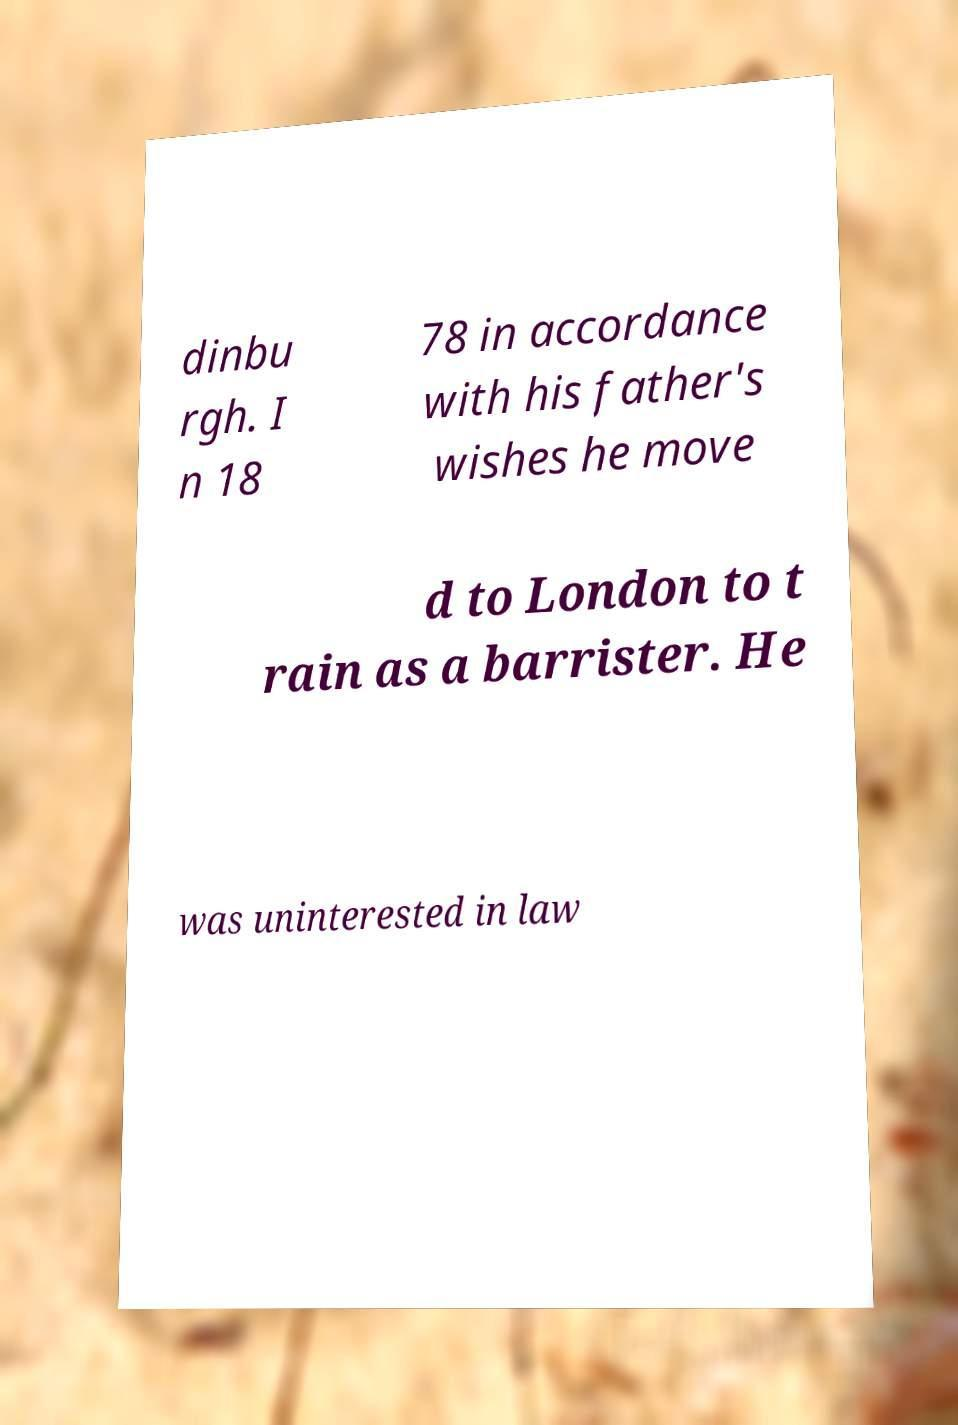What messages or text are displayed in this image? I need them in a readable, typed format. dinbu rgh. I n 18 78 in accordance with his father's wishes he move d to London to t rain as a barrister. He was uninterested in law 